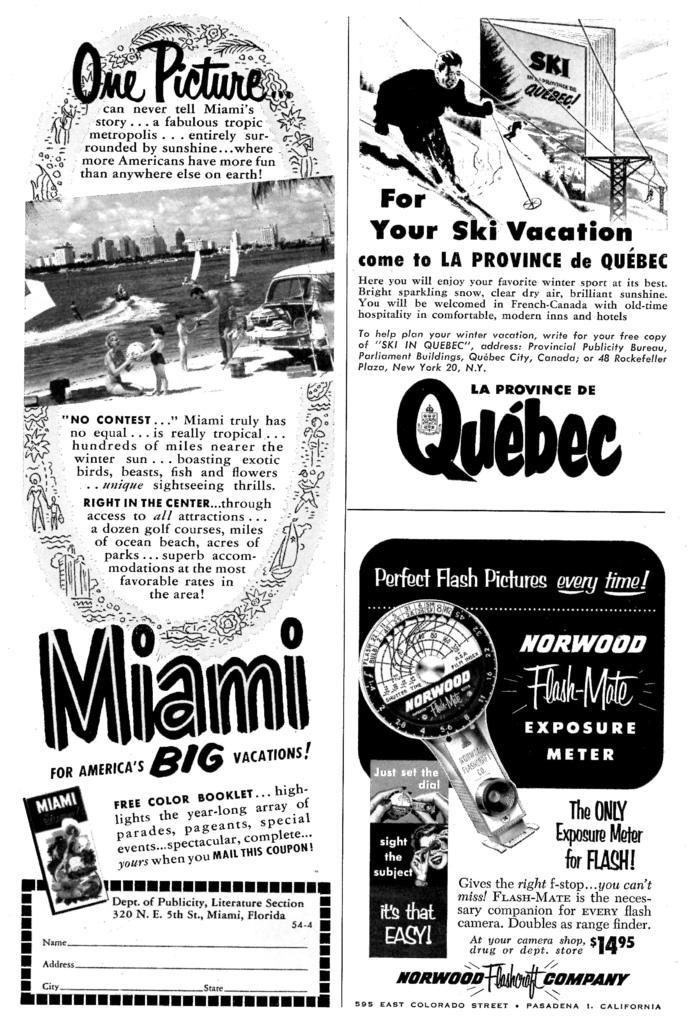How would you summarize this image in a sentence or two? This is an edited image in which there is some text and there are images of the persons. 